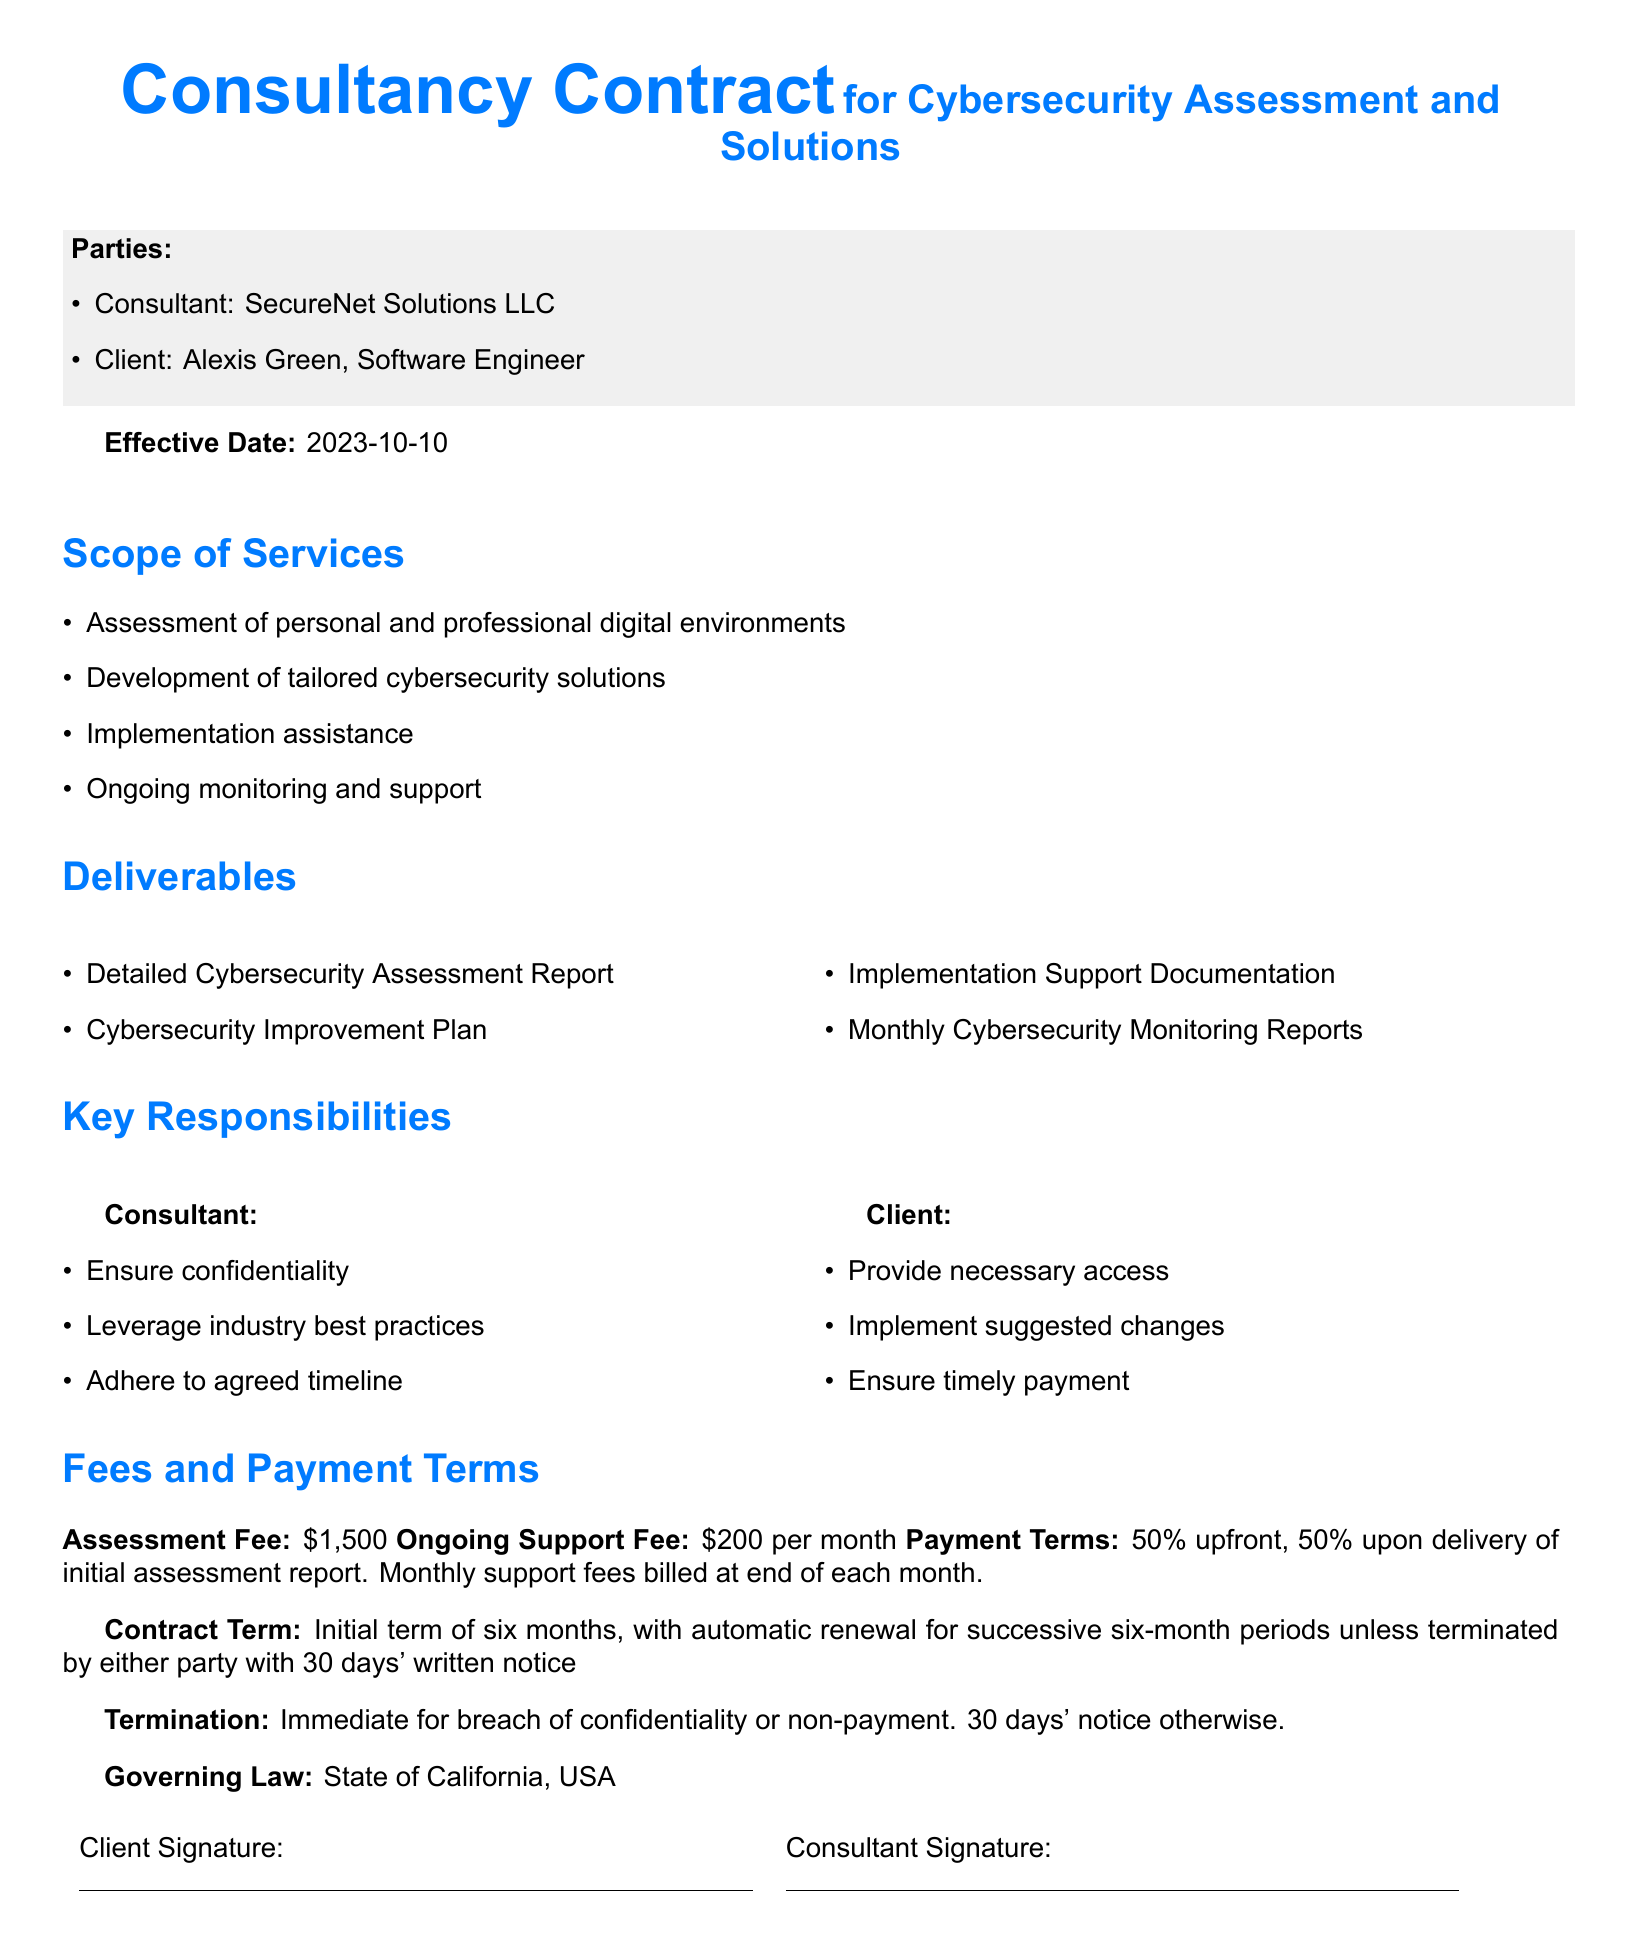What is the name of the consultant? The document states the consultant's name as SecureNet Solutions LLC.
Answer: SecureNet Solutions LLC Who is the client named in the contract? The client mentioned in the contract is Alexis Green.
Answer: Alexis Green What is the effective date of the contract? The contract specifies the effective date as October 10, 2023.
Answer: 2023-10-10 What is the assessment fee outlined in the contract? The assessment fee listed in the document is $1,500.
Answer: $1,500 What is the initial term of the contract? According to the document, the initial term is six months.
Answer: six months What is the ongoing support fee per month? The ongoing support fee is stated as $200 per month in the contract.
Answer: $200 per month What consequence is outlined for breach of confidentiality? The document indicates that immediate termination can occur for breach of confidentiality.
Answer: Immediate Under which state’s law is the contract governed? The governing law specified in the contract is the State of California.
Answer: State of California What is one of the key responsibilities of the consultant? One key responsibility of the consultant, as mentioned in the document, is to ensure confidentiality.
Answer: Ensure confidentiality 